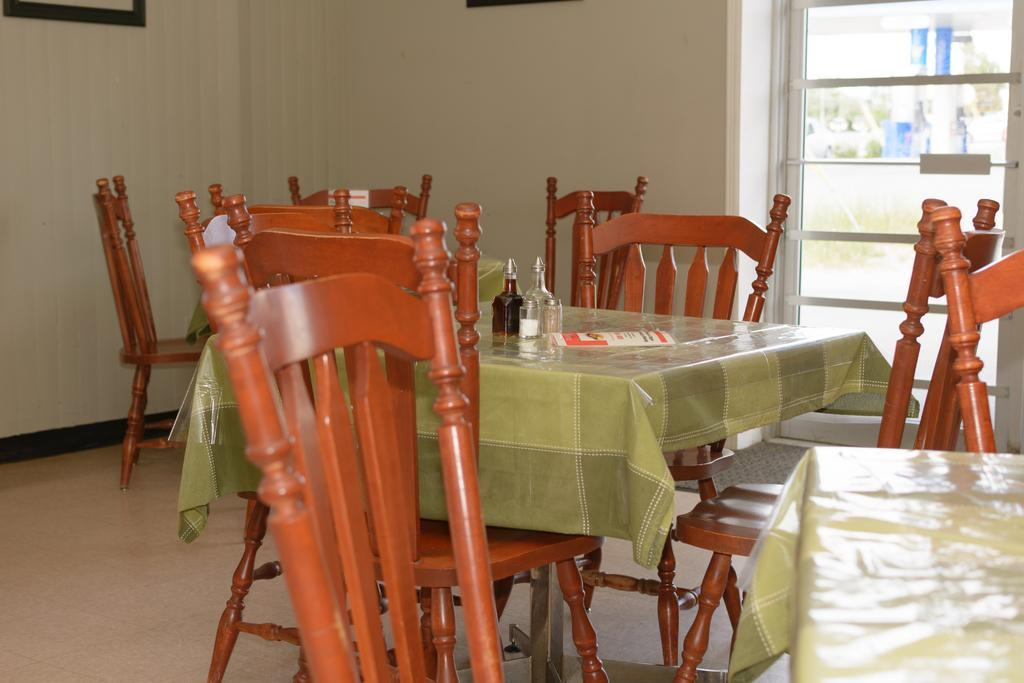What type of furniture is present in the image? There are tables and chairs in the image. How many bottles can be seen on a table in the image? There are 2 bottles on a table in the image. What part of the room is visible in the image? The floor is visible in the image. What can be seen in the background of the image? There is a wall in the background of the image. What architectural feature is present on the right side of the image? There is a window on the right side of the image. Can you tell me the statement made by the kitten in the image? There is no kitten present in the image, so no statement can be attributed to it. What type of truck is visible through the window in the image? There is no truck visible through the window in the image; only the window and the outdoor scene beyond it are present. 